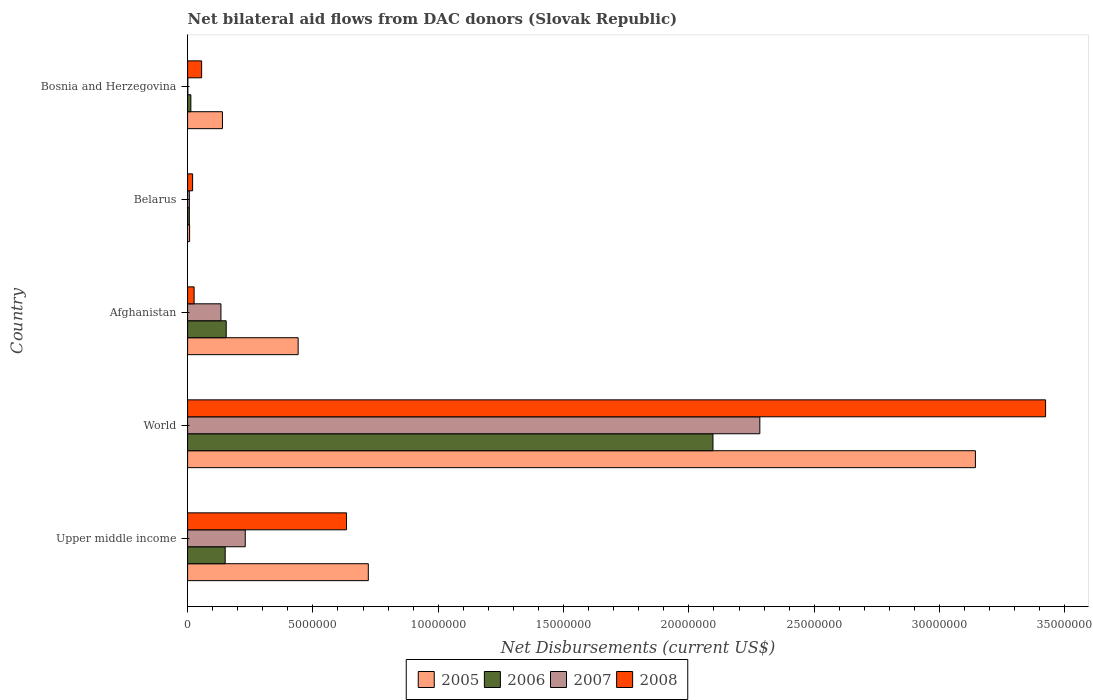How many different coloured bars are there?
Your answer should be very brief. 4. How many groups of bars are there?
Keep it short and to the point. 5. Are the number of bars per tick equal to the number of legend labels?
Your response must be concise. Yes. How many bars are there on the 4th tick from the top?
Provide a short and direct response. 4. How many bars are there on the 4th tick from the bottom?
Your answer should be very brief. 4. What is the label of the 4th group of bars from the top?
Give a very brief answer. World. In how many cases, is the number of bars for a given country not equal to the number of legend labels?
Your answer should be compact. 0. What is the net bilateral aid flows in 2005 in Upper middle income?
Give a very brief answer. 7.21e+06. Across all countries, what is the maximum net bilateral aid flows in 2008?
Keep it short and to the point. 3.42e+07. Across all countries, what is the minimum net bilateral aid flows in 2008?
Your answer should be compact. 2.00e+05. In which country was the net bilateral aid flows in 2006 minimum?
Provide a succinct answer. Belarus. What is the total net bilateral aid flows in 2005 in the graph?
Offer a very short reply. 4.45e+07. What is the difference between the net bilateral aid flows in 2007 in Afghanistan and that in Belarus?
Your response must be concise. 1.26e+06. What is the difference between the net bilateral aid flows in 2006 in Afghanistan and the net bilateral aid flows in 2007 in Bosnia and Herzegovina?
Provide a succinct answer. 1.53e+06. What is the average net bilateral aid flows in 2007 per country?
Keep it short and to the point. 5.31e+06. What is the ratio of the net bilateral aid flows in 2007 in Afghanistan to that in Upper middle income?
Make the answer very short. 0.58. Is the difference between the net bilateral aid flows in 2008 in Afghanistan and World greater than the difference between the net bilateral aid flows in 2007 in Afghanistan and World?
Ensure brevity in your answer.  No. What is the difference between the highest and the second highest net bilateral aid flows in 2008?
Make the answer very short. 2.79e+07. What is the difference between the highest and the lowest net bilateral aid flows in 2007?
Make the answer very short. 2.28e+07. Is the sum of the net bilateral aid flows in 2005 in Upper middle income and World greater than the maximum net bilateral aid flows in 2007 across all countries?
Offer a terse response. Yes. Is it the case that in every country, the sum of the net bilateral aid flows in 2007 and net bilateral aid flows in 2005 is greater than the sum of net bilateral aid flows in 2008 and net bilateral aid flows in 2006?
Your answer should be very brief. No. What does the 2nd bar from the top in Upper middle income represents?
Keep it short and to the point. 2007. Is it the case that in every country, the sum of the net bilateral aid flows in 2008 and net bilateral aid flows in 2005 is greater than the net bilateral aid flows in 2007?
Your answer should be very brief. Yes. How many bars are there?
Ensure brevity in your answer.  20. Are all the bars in the graph horizontal?
Your response must be concise. Yes. What is the difference between two consecutive major ticks on the X-axis?
Give a very brief answer. 5.00e+06. Are the values on the major ticks of X-axis written in scientific E-notation?
Provide a short and direct response. No. Does the graph contain grids?
Keep it short and to the point. No. Where does the legend appear in the graph?
Offer a very short reply. Bottom center. How are the legend labels stacked?
Give a very brief answer. Horizontal. What is the title of the graph?
Provide a succinct answer. Net bilateral aid flows from DAC donors (Slovak Republic). What is the label or title of the X-axis?
Provide a succinct answer. Net Disbursements (current US$). What is the label or title of the Y-axis?
Keep it short and to the point. Country. What is the Net Disbursements (current US$) of 2005 in Upper middle income?
Provide a succinct answer. 7.21e+06. What is the Net Disbursements (current US$) of 2006 in Upper middle income?
Your answer should be compact. 1.50e+06. What is the Net Disbursements (current US$) of 2007 in Upper middle income?
Offer a very short reply. 2.30e+06. What is the Net Disbursements (current US$) in 2008 in Upper middle income?
Ensure brevity in your answer.  6.34e+06. What is the Net Disbursements (current US$) in 2005 in World?
Your response must be concise. 3.14e+07. What is the Net Disbursements (current US$) of 2006 in World?
Provide a short and direct response. 2.10e+07. What is the Net Disbursements (current US$) of 2007 in World?
Offer a very short reply. 2.28e+07. What is the Net Disbursements (current US$) of 2008 in World?
Ensure brevity in your answer.  3.42e+07. What is the Net Disbursements (current US$) in 2005 in Afghanistan?
Your response must be concise. 4.41e+06. What is the Net Disbursements (current US$) in 2006 in Afghanistan?
Your answer should be compact. 1.54e+06. What is the Net Disbursements (current US$) in 2007 in Afghanistan?
Provide a succinct answer. 1.33e+06. What is the Net Disbursements (current US$) of 2005 in Belarus?
Ensure brevity in your answer.  8.00e+04. What is the Net Disbursements (current US$) of 2006 in Belarus?
Give a very brief answer. 7.00e+04. What is the Net Disbursements (current US$) of 2007 in Belarus?
Make the answer very short. 7.00e+04. What is the Net Disbursements (current US$) in 2005 in Bosnia and Herzegovina?
Your response must be concise. 1.39e+06. What is the Net Disbursements (current US$) of 2006 in Bosnia and Herzegovina?
Offer a terse response. 1.30e+05. What is the Net Disbursements (current US$) of 2007 in Bosnia and Herzegovina?
Offer a very short reply. 10000. What is the Net Disbursements (current US$) in 2008 in Bosnia and Herzegovina?
Ensure brevity in your answer.  5.60e+05. Across all countries, what is the maximum Net Disbursements (current US$) of 2005?
Offer a very short reply. 3.14e+07. Across all countries, what is the maximum Net Disbursements (current US$) in 2006?
Ensure brevity in your answer.  2.10e+07. Across all countries, what is the maximum Net Disbursements (current US$) of 2007?
Give a very brief answer. 2.28e+07. Across all countries, what is the maximum Net Disbursements (current US$) of 2008?
Give a very brief answer. 3.42e+07. Across all countries, what is the minimum Net Disbursements (current US$) of 2005?
Make the answer very short. 8.00e+04. Across all countries, what is the minimum Net Disbursements (current US$) in 2006?
Provide a succinct answer. 7.00e+04. Across all countries, what is the minimum Net Disbursements (current US$) in 2008?
Keep it short and to the point. 2.00e+05. What is the total Net Disbursements (current US$) of 2005 in the graph?
Keep it short and to the point. 4.45e+07. What is the total Net Disbursements (current US$) of 2006 in the graph?
Offer a terse response. 2.42e+07. What is the total Net Disbursements (current US$) of 2007 in the graph?
Offer a very short reply. 2.65e+07. What is the total Net Disbursements (current US$) of 2008 in the graph?
Ensure brevity in your answer.  4.16e+07. What is the difference between the Net Disbursements (current US$) of 2005 in Upper middle income and that in World?
Your answer should be very brief. -2.42e+07. What is the difference between the Net Disbursements (current US$) of 2006 in Upper middle income and that in World?
Make the answer very short. -1.95e+07. What is the difference between the Net Disbursements (current US$) of 2007 in Upper middle income and that in World?
Provide a succinct answer. -2.05e+07. What is the difference between the Net Disbursements (current US$) in 2008 in Upper middle income and that in World?
Make the answer very short. -2.79e+07. What is the difference between the Net Disbursements (current US$) in 2005 in Upper middle income and that in Afghanistan?
Your response must be concise. 2.80e+06. What is the difference between the Net Disbursements (current US$) in 2007 in Upper middle income and that in Afghanistan?
Provide a short and direct response. 9.70e+05. What is the difference between the Net Disbursements (current US$) of 2008 in Upper middle income and that in Afghanistan?
Offer a terse response. 6.08e+06. What is the difference between the Net Disbursements (current US$) in 2005 in Upper middle income and that in Belarus?
Provide a succinct answer. 7.13e+06. What is the difference between the Net Disbursements (current US$) in 2006 in Upper middle income and that in Belarus?
Ensure brevity in your answer.  1.43e+06. What is the difference between the Net Disbursements (current US$) in 2007 in Upper middle income and that in Belarus?
Offer a terse response. 2.23e+06. What is the difference between the Net Disbursements (current US$) of 2008 in Upper middle income and that in Belarus?
Ensure brevity in your answer.  6.14e+06. What is the difference between the Net Disbursements (current US$) in 2005 in Upper middle income and that in Bosnia and Herzegovina?
Offer a terse response. 5.82e+06. What is the difference between the Net Disbursements (current US$) of 2006 in Upper middle income and that in Bosnia and Herzegovina?
Offer a very short reply. 1.37e+06. What is the difference between the Net Disbursements (current US$) in 2007 in Upper middle income and that in Bosnia and Herzegovina?
Keep it short and to the point. 2.29e+06. What is the difference between the Net Disbursements (current US$) in 2008 in Upper middle income and that in Bosnia and Herzegovina?
Make the answer very short. 5.78e+06. What is the difference between the Net Disbursements (current US$) in 2005 in World and that in Afghanistan?
Your answer should be compact. 2.70e+07. What is the difference between the Net Disbursements (current US$) in 2006 in World and that in Afghanistan?
Offer a terse response. 1.94e+07. What is the difference between the Net Disbursements (current US$) in 2007 in World and that in Afghanistan?
Offer a very short reply. 2.15e+07. What is the difference between the Net Disbursements (current US$) in 2008 in World and that in Afghanistan?
Ensure brevity in your answer.  3.40e+07. What is the difference between the Net Disbursements (current US$) of 2005 in World and that in Belarus?
Provide a short and direct response. 3.14e+07. What is the difference between the Net Disbursements (current US$) of 2006 in World and that in Belarus?
Your answer should be compact. 2.09e+07. What is the difference between the Net Disbursements (current US$) of 2007 in World and that in Belarus?
Make the answer very short. 2.28e+07. What is the difference between the Net Disbursements (current US$) in 2008 in World and that in Belarus?
Your answer should be compact. 3.40e+07. What is the difference between the Net Disbursements (current US$) of 2005 in World and that in Bosnia and Herzegovina?
Offer a terse response. 3.00e+07. What is the difference between the Net Disbursements (current US$) in 2006 in World and that in Bosnia and Herzegovina?
Keep it short and to the point. 2.08e+07. What is the difference between the Net Disbursements (current US$) of 2007 in World and that in Bosnia and Herzegovina?
Ensure brevity in your answer.  2.28e+07. What is the difference between the Net Disbursements (current US$) of 2008 in World and that in Bosnia and Herzegovina?
Ensure brevity in your answer.  3.37e+07. What is the difference between the Net Disbursements (current US$) in 2005 in Afghanistan and that in Belarus?
Make the answer very short. 4.33e+06. What is the difference between the Net Disbursements (current US$) of 2006 in Afghanistan and that in Belarus?
Your response must be concise. 1.47e+06. What is the difference between the Net Disbursements (current US$) of 2007 in Afghanistan and that in Belarus?
Your answer should be compact. 1.26e+06. What is the difference between the Net Disbursements (current US$) in 2005 in Afghanistan and that in Bosnia and Herzegovina?
Provide a succinct answer. 3.02e+06. What is the difference between the Net Disbursements (current US$) in 2006 in Afghanistan and that in Bosnia and Herzegovina?
Your answer should be very brief. 1.41e+06. What is the difference between the Net Disbursements (current US$) of 2007 in Afghanistan and that in Bosnia and Herzegovina?
Ensure brevity in your answer.  1.32e+06. What is the difference between the Net Disbursements (current US$) of 2005 in Belarus and that in Bosnia and Herzegovina?
Provide a succinct answer. -1.31e+06. What is the difference between the Net Disbursements (current US$) of 2008 in Belarus and that in Bosnia and Herzegovina?
Offer a terse response. -3.60e+05. What is the difference between the Net Disbursements (current US$) in 2005 in Upper middle income and the Net Disbursements (current US$) in 2006 in World?
Make the answer very short. -1.38e+07. What is the difference between the Net Disbursements (current US$) of 2005 in Upper middle income and the Net Disbursements (current US$) of 2007 in World?
Offer a very short reply. -1.56e+07. What is the difference between the Net Disbursements (current US$) of 2005 in Upper middle income and the Net Disbursements (current US$) of 2008 in World?
Ensure brevity in your answer.  -2.70e+07. What is the difference between the Net Disbursements (current US$) of 2006 in Upper middle income and the Net Disbursements (current US$) of 2007 in World?
Your answer should be very brief. -2.13e+07. What is the difference between the Net Disbursements (current US$) of 2006 in Upper middle income and the Net Disbursements (current US$) of 2008 in World?
Make the answer very short. -3.27e+07. What is the difference between the Net Disbursements (current US$) in 2007 in Upper middle income and the Net Disbursements (current US$) in 2008 in World?
Make the answer very short. -3.19e+07. What is the difference between the Net Disbursements (current US$) of 2005 in Upper middle income and the Net Disbursements (current US$) of 2006 in Afghanistan?
Offer a very short reply. 5.67e+06. What is the difference between the Net Disbursements (current US$) of 2005 in Upper middle income and the Net Disbursements (current US$) of 2007 in Afghanistan?
Your answer should be compact. 5.88e+06. What is the difference between the Net Disbursements (current US$) of 2005 in Upper middle income and the Net Disbursements (current US$) of 2008 in Afghanistan?
Keep it short and to the point. 6.95e+06. What is the difference between the Net Disbursements (current US$) in 2006 in Upper middle income and the Net Disbursements (current US$) in 2008 in Afghanistan?
Your answer should be very brief. 1.24e+06. What is the difference between the Net Disbursements (current US$) of 2007 in Upper middle income and the Net Disbursements (current US$) of 2008 in Afghanistan?
Make the answer very short. 2.04e+06. What is the difference between the Net Disbursements (current US$) of 2005 in Upper middle income and the Net Disbursements (current US$) of 2006 in Belarus?
Your response must be concise. 7.14e+06. What is the difference between the Net Disbursements (current US$) in 2005 in Upper middle income and the Net Disbursements (current US$) in 2007 in Belarus?
Your answer should be very brief. 7.14e+06. What is the difference between the Net Disbursements (current US$) in 2005 in Upper middle income and the Net Disbursements (current US$) in 2008 in Belarus?
Your answer should be compact. 7.01e+06. What is the difference between the Net Disbursements (current US$) of 2006 in Upper middle income and the Net Disbursements (current US$) of 2007 in Belarus?
Your response must be concise. 1.43e+06. What is the difference between the Net Disbursements (current US$) in 2006 in Upper middle income and the Net Disbursements (current US$) in 2008 in Belarus?
Make the answer very short. 1.30e+06. What is the difference between the Net Disbursements (current US$) in 2007 in Upper middle income and the Net Disbursements (current US$) in 2008 in Belarus?
Provide a succinct answer. 2.10e+06. What is the difference between the Net Disbursements (current US$) of 2005 in Upper middle income and the Net Disbursements (current US$) of 2006 in Bosnia and Herzegovina?
Offer a terse response. 7.08e+06. What is the difference between the Net Disbursements (current US$) in 2005 in Upper middle income and the Net Disbursements (current US$) in 2007 in Bosnia and Herzegovina?
Provide a short and direct response. 7.20e+06. What is the difference between the Net Disbursements (current US$) of 2005 in Upper middle income and the Net Disbursements (current US$) of 2008 in Bosnia and Herzegovina?
Your response must be concise. 6.65e+06. What is the difference between the Net Disbursements (current US$) of 2006 in Upper middle income and the Net Disbursements (current US$) of 2007 in Bosnia and Herzegovina?
Give a very brief answer. 1.49e+06. What is the difference between the Net Disbursements (current US$) in 2006 in Upper middle income and the Net Disbursements (current US$) in 2008 in Bosnia and Herzegovina?
Keep it short and to the point. 9.40e+05. What is the difference between the Net Disbursements (current US$) of 2007 in Upper middle income and the Net Disbursements (current US$) of 2008 in Bosnia and Herzegovina?
Your answer should be compact. 1.74e+06. What is the difference between the Net Disbursements (current US$) in 2005 in World and the Net Disbursements (current US$) in 2006 in Afghanistan?
Make the answer very short. 2.99e+07. What is the difference between the Net Disbursements (current US$) in 2005 in World and the Net Disbursements (current US$) in 2007 in Afghanistan?
Provide a succinct answer. 3.01e+07. What is the difference between the Net Disbursements (current US$) of 2005 in World and the Net Disbursements (current US$) of 2008 in Afghanistan?
Provide a succinct answer. 3.12e+07. What is the difference between the Net Disbursements (current US$) of 2006 in World and the Net Disbursements (current US$) of 2007 in Afghanistan?
Make the answer very short. 1.96e+07. What is the difference between the Net Disbursements (current US$) of 2006 in World and the Net Disbursements (current US$) of 2008 in Afghanistan?
Keep it short and to the point. 2.07e+07. What is the difference between the Net Disbursements (current US$) in 2007 in World and the Net Disbursements (current US$) in 2008 in Afghanistan?
Offer a very short reply. 2.26e+07. What is the difference between the Net Disbursements (current US$) in 2005 in World and the Net Disbursements (current US$) in 2006 in Belarus?
Make the answer very short. 3.14e+07. What is the difference between the Net Disbursements (current US$) of 2005 in World and the Net Disbursements (current US$) of 2007 in Belarus?
Keep it short and to the point. 3.14e+07. What is the difference between the Net Disbursements (current US$) of 2005 in World and the Net Disbursements (current US$) of 2008 in Belarus?
Give a very brief answer. 3.12e+07. What is the difference between the Net Disbursements (current US$) of 2006 in World and the Net Disbursements (current US$) of 2007 in Belarus?
Make the answer very short. 2.09e+07. What is the difference between the Net Disbursements (current US$) in 2006 in World and the Net Disbursements (current US$) in 2008 in Belarus?
Make the answer very short. 2.08e+07. What is the difference between the Net Disbursements (current US$) of 2007 in World and the Net Disbursements (current US$) of 2008 in Belarus?
Keep it short and to the point. 2.26e+07. What is the difference between the Net Disbursements (current US$) of 2005 in World and the Net Disbursements (current US$) of 2006 in Bosnia and Herzegovina?
Your answer should be compact. 3.13e+07. What is the difference between the Net Disbursements (current US$) of 2005 in World and the Net Disbursements (current US$) of 2007 in Bosnia and Herzegovina?
Offer a very short reply. 3.14e+07. What is the difference between the Net Disbursements (current US$) in 2005 in World and the Net Disbursements (current US$) in 2008 in Bosnia and Herzegovina?
Offer a very short reply. 3.09e+07. What is the difference between the Net Disbursements (current US$) of 2006 in World and the Net Disbursements (current US$) of 2007 in Bosnia and Herzegovina?
Make the answer very short. 2.10e+07. What is the difference between the Net Disbursements (current US$) of 2006 in World and the Net Disbursements (current US$) of 2008 in Bosnia and Herzegovina?
Your answer should be very brief. 2.04e+07. What is the difference between the Net Disbursements (current US$) of 2007 in World and the Net Disbursements (current US$) of 2008 in Bosnia and Herzegovina?
Offer a very short reply. 2.23e+07. What is the difference between the Net Disbursements (current US$) of 2005 in Afghanistan and the Net Disbursements (current US$) of 2006 in Belarus?
Offer a very short reply. 4.34e+06. What is the difference between the Net Disbursements (current US$) in 2005 in Afghanistan and the Net Disbursements (current US$) in 2007 in Belarus?
Your answer should be very brief. 4.34e+06. What is the difference between the Net Disbursements (current US$) in 2005 in Afghanistan and the Net Disbursements (current US$) in 2008 in Belarus?
Your answer should be compact. 4.21e+06. What is the difference between the Net Disbursements (current US$) of 2006 in Afghanistan and the Net Disbursements (current US$) of 2007 in Belarus?
Offer a very short reply. 1.47e+06. What is the difference between the Net Disbursements (current US$) in 2006 in Afghanistan and the Net Disbursements (current US$) in 2008 in Belarus?
Offer a terse response. 1.34e+06. What is the difference between the Net Disbursements (current US$) of 2007 in Afghanistan and the Net Disbursements (current US$) of 2008 in Belarus?
Provide a short and direct response. 1.13e+06. What is the difference between the Net Disbursements (current US$) of 2005 in Afghanistan and the Net Disbursements (current US$) of 2006 in Bosnia and Herzegovina?
Your answer should be compact. 4.28e+06. What is the difference between the Net Disbursements (current US$) in 2005 in Afghanistan and the Net Disbursements (current US$) in 2007 in Bosnia and Herzegovina?
Offer a terse response. 4.40e+06. What is the difference between the Net Disbursements (current US$) of 2005 in Afghanistan and the Net Disbursements (current US$) of 2008 in Bosnia and Herzegovina?
Keep it short and to the point. 3.85e+06. What is the difference between the Net Disbursements (current US$) of 2006 in Afghanistan and the Net Disbursements (current US$) of 2007 in Bosnia and Herzegovina?
Your answer should be very brief. 1.53e+06. What is the difference between the Net Disbursements (current US$) in 2006 in Afghanistan and the Net Disbursements (current US$) in 2008 in Bosnia and Herzegovina?
Your response must be concise. 9.80e+05. What is the difference between the Net Disbursements (current US$) of 2007 in Afghanistan and the Net Disbursements (current US$) of 2008 in Bosnia and Herzegovina?
Your answer should be very brief. 7.70e+05. What is the difference between the Net Disbursements (current US$) in 2005 in Belarus and the Net Disbursements (current US$) in 2007 in Bosnia and Herzegovina?
Your response must be concise. 7.00e+04. What is the difference between the Net Disbursements (current US$) in 2005 in Belarus and the Net Disbursements (current US$) in 2008 in Bosnia and Herzegovina?
Make the answer very short. -4.80e+05. What is the difference between the Net Disbursements (current US$) of 2006 in Belarus and the Net Disbursements (current US$) of 2008 in Bosnia and Herzegovina?
Provide a short and direct response. -4.90e+05. What is the difference between the Net Disbursements (current US$) of 2007 in Belarus and the Net Disbursements (current US$) of 2008 in Bosnia and Herzegovina?
Make the answer very short. -4.90e+05. What is the average Net Disbursements (current US$) of 2005 per country?
Provide a succinct answer. 8.90e+06. What is the average Net Disbursements (current US$) in 2006 per country?
Provide a succinct answer. 4.84e+06. What is the average Net Disbursements (current US$) in 2007 per country?
Ensure brevity in your answer.  5.31e+06. What is the average Net Disbursements (current US$) in 2008 per country?
Keep it short and to the point. 8.32e+06. What is the difference between the Net Disbursements (current US$) of 2005 and Net Disbursements (current US$) of 2006 in Upper middle income?
Give a very brief answer. 5.71e+06. What is the difference between the Net Disbursements (current US$) of 2005 and Net Disbursements (current US$) of 2007 in Upper middle income?
Your answer should be compact. 4.91e+06. What is the difference between the Net Disbursements (current US$) in 2005 and Net Disbursements (current US$) in 2008 in Upper middle income?
Your answer should be compact. 8.70e+05. What is the difference between the Net Disbursements (current US$) of 2006 and Net Disbursements (current US$) of 2007 in Upper middle income?
Make the answer very short. -8.00e+05. What is the difference between the Net Disbursements (current US$) in 2006 and Net Disbursements (current US$) in 2008 in Upper middle income?
Provide a short and direct response. -4.84e+06. What is the difference between the Net Disbursements (current US$) in 2007 and Net Disbursements (current US$) in 2008 in Upper middle income?
Offer a terse response. -4.04e+06. What is the difference between the Net Disbursements (current US$) of 2005 and Net Disbursements (current US$) of 2006 in World?
Ensure brevity in your answer.  1.05e+07. What is the difference between the Net Disbursements (current US$) in 2005 and Net Disbursements (current US$) in 2007 in World?
Your answer should be compact. 8.60e+06. What is the difference between the Net Disbursements (current US$) in 2005 and Net Disbursements (current US$) in 2008 in World?
Offer a very short reply. -2.80e+06. What is the difference between the Net Disbursements (current US$) in 2006 and Net Disbursements (current US$) in 2007 in World?
Your answer should be compact. -1.87e+06. What is the difference between the Net Disbursements (current US$) of 2006 and Net Disbursements (current US$) of 2008 in World?
Keep it short and to the point. -1.33e+07. What is the difference between the Net Disbursements (current US$) of 2007 and Net Disbursements (current US$) of 2008 in World?
Your response must be concise. -1.14e+07. What is the difference between the Net Disbursements (current US$) of 2005 and Net Disbursements (current US$) of 2006 in Afghanistan?
Offer a terse response. 2.87e+06. What is the difference between the Net Disbursements (current US$) in 2005 and Net Disbursements (current US$) in 2007 in Afghanistan?
Offer a very short reply. 3.08e+06. What is the difference between the Net Disbursements (current US$) in 2005 and Net Disbursements (current US$) in 2008 in Afghanistan?
Make the answer very short. 4.15e+06. What is the difference between the Net Disbursements (current US$) in 2006 and Net Disbursements (current US$) in 2008 in Afghanistan?
Keep it short and to the point. 1.28e+06. What is the difference between the Net Disbursements (current US$) in 2007 and Net Disbursements (current US$) in 2008 in Afghanistan?
Your answer should be compact. 1.07e+06. What is the difference between the Net Disbursements (current US$) in 2005 and Net Disbursements (current US$) in 2006 in Belarus?
Make the answer very short. 10000. What is the difference between the Net Disbursements (current US$) in 2005 and Net Disbursements (current US$) in 2007 in Belarus?
Provide a succinct answer. 10000. What is the difference between the Net Disbursements (current US$) in 2006 and Net Disbursements (current US$) in 2008 in Belarus?
Make the answer very short. -1.30e+05. What is the difference between the Net Disbursements (current US$) in 2005 and Net Disbursements (current US$) in 2006 in Bosnia and Herzegovina?
Provide a succinct answer. 1.26e+06. What is the difference between the Net Disbursements (current US$) in 2005 and Net Disbursements (current US$) in 2007 in Bosnia and Herzegovina?
Give a very brief answer. 1.38e+06. What is the difference between the Net Disbursements (current US$) in 2005 and Net Disbursements (current US$) in 2008 in Bosnia and Herzegovina?
Keep it short and to the point. 8.30e+05. What is the difference between the Net Disbursements (current US$) in 2006 and Net Disbursements (current US$) in 2007 in Bosnia and Herzegovina?
Make the answer very short. 1.20e+05. What is the difference between the Net Disbursements (current US$) in 2006 and Net Disbursements (current US$) in 2008 in Bosnia and Herzegovina?
Provide a succinct answer. -4.30e+05. What is the difference between the Net Disbursements (current US$) in 2007 and Net Disbursements (current US$) in 2008 in Bosnia and Herzegovina?
Offer a very short reply. -5.50e+05. What is the ratio of the Net Disbursements (current US$) in 2005 in Upper middle income to that in World?
Offer a terse response. 0.23. What is the ratio of the Net Disbursements (current US$) of 2006 in Upper middle income to that in World?
Ensure brevity in your answer.  0.07. What is the ratio of the Net Disbursements (current US$) in 2007 in Upper middle income to that in World?
Offer a very short reply. 0.1. What is the ratio of the Net Disbursements (current US$) of 2008 in Upper middle income to that in World?
Provide a short and direct response. 0.19. What is the ratio of the Net Disbursements (current US$) in 2005 in Upper middle income to that in Afghanistan?
Your answer should be very brief. 1.63. What is the ratio of the Net Disbursements (current US$) in 2007 in Upper middle income to that in Afghanistan?
Keep it short and to the point. 1.73. What is the ratio of the Net Disbursements (current US$) of 2008 in Upper middle income to that in Afghanistan?
Your answer should be very brief. 24.38. What is the ratio of the Net Disbursements (current US$) in 2005 in Upper middle income to that in Belarus?
Your answer should be compact. 90.12. What is the ratio of the Net Disbursements (current US$) of 2006 in Upper middle income to that in Belarus?
Provide a succinct answer. 21.43. What is the ratio of the Net Disbursements (current US$) in 2007 in Upper middle income to that in Belarus?
Your answer should be very brief. 32.86. What is the ratio of the Net Disbursements (current US$) in 2008 in Upper middle income to that in Belarus?
Your answer should be very brief. 31.7. What is the ratio of the Net Disbursements (current US$) in 2005 in Upper middle income to that in Bosnia and Herzegovina?
Provide a succinct answer. 5.19. What is the ratio of the Net Disbursements (current US$) of 2006 in Upper middle income to that in Bosnia and Herzegovina?
Provide a short and direct response. 11.54. What is the ratio of the Net Disbursements (current US$) of 2007 in Upper middle income to that in Bosnia and Herzegovina?
Make the answer very short. 230. What is the ratio of the Net Disbursements (current US$) of 2008 in Upper middle income to that in Bosnia and Herzegovina?
Your response must be concise. 11.32. What is the ratio of the Net Disbursements (current US$) of 2005 in World to that in Afghanistan?
Offer a terse response. 7.13. What is the ratio of the Net Disbursements (current US$) in 2006 in World to that in Afghanistan?
Offer a terse response. 13.61. What is the ratio of the Net Disbursements (current US$) of 2007 in World to that in Afghanistan?
Provide a succinct answer. 17.17. What is the ratio of the Net Disbursements (current US$) of 2008 in World to that in Afghanistan?
Provide a succinct answer. 131.65. What is the ratio of the Net Disbursements (current US$) in 2005 in World to that in Belarus?
Ensure brevity in your answer.  392.88. What is the ratio of the Net Disbursements (current US$) in 2006 in World to that in Belarus?
Make the answer very short. 299.43. What is the ratio of the Net Disbursements (current US$) in 2007 in World to that in Belarus?
Provide a short and direct response. 326.14. What is the ratio of the Net Disbursements (current US$) in 2008 in World to that in Belarus?
Offer a very short reply. 171.15. What is the ratio of the Net Disbursements (current US$) in 2005 in World to that in Bosnia and Herzegovina?
Your answer should be compact. 22.61. What is the ratio of the Net Disbursements (current US$) in 2006 in World to that in Bosnia and Herzegovina?
Ensure brevity in your answer.  161.23. What is the ratio of the Net Disbursements (current US$) in 2007 in World to that in Bosnia and Herzegovina?
Your answer should be very brief. 2283. What is the ratio of the Net Disbursements (current US$) of 2008 in World to that in Bosnia and Herzegovina?
Make the answer very short. 61.12. What is the ratio of the Net Disbursements (current US$) of 2005 in Afghanistan to that in Belarus?
Make the answer very short. 55.12. What is the ratio of the Net Disbursements (current US$) in 2005 in Afghanistan to that in Bosnia and Herzegovina?
Your answer should be compact. 3.17. What is the ratio of the Net Disbursements (current US$) of 2006 in Afghanistan to that in Bosnia and Herzegovina?
Offer a very short reply. 11.85. What is the ratio of the Net Disbursements (current US$) of 2007 in Afghanistan to that in Bosnia and Herzegovina?
Offer a terse response. 133. What is the ratio of the Net Disbursements (current US$) of 2008 in Afghanistan to that in Bosnia and Herzegovina?
Offer a terse response. 0.46. What is the ratio of the Net Disbursements (current US$) of 2005 in Belarus to that in Bosnia and Herzegovina?
Give a very brief answer. 0.06. What is the ratio of the Net Disbursements (current US$) in 2006 in Belarus to that in Bosnia and Herzegovina?
Your response must be concise. 0.54. What is the ratio of the Net Disbursements (current US$) in 2008 in Belarus to that in Bosnia and Herzegovina?
Your response must be concise. 0.36. What is the difference between the highest and the second highest Net Disbursements (current US$) of 2005?
Provide a short and direct response. 2.42e+07. What is the difference between the highest and the second highest Net Disbursements (current US$) in 2006?
Ensure brevity in your answer.  1.94e+07. What is the difference between the highest and the second highest Net Disbursements (current US$) in 2007?
Your answer should be compact. 2.05e+07. What is the difference between the highest and the second highest Net Disbursements (current US$) of 2008?
Offer a terse response. 2.79e+07. What is the difference between the highest and the lowest Net Disbursements (current US$) in 2005?
Provide a short and direct response. 3.14e+07. What is the difference between the highest and the lowest Net Disbursements (current US$) in 2006?
Your response must be concise. 2.09e+07. What is the difference between the highest and the lowest Net Disbursements (current US$) of 2007?
Offer a terse response. 2.28e+07. What is the difference between the highest and the lowest Net Disbursements (current US$) in 2008?
Make the answer very short. 3.40e+07. 